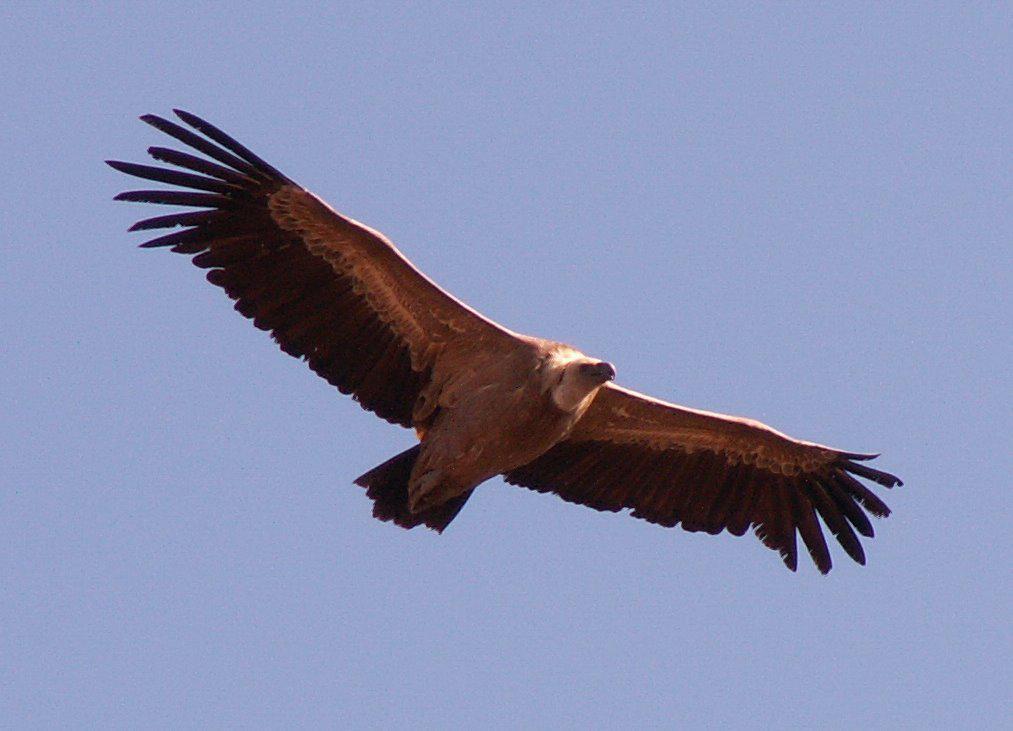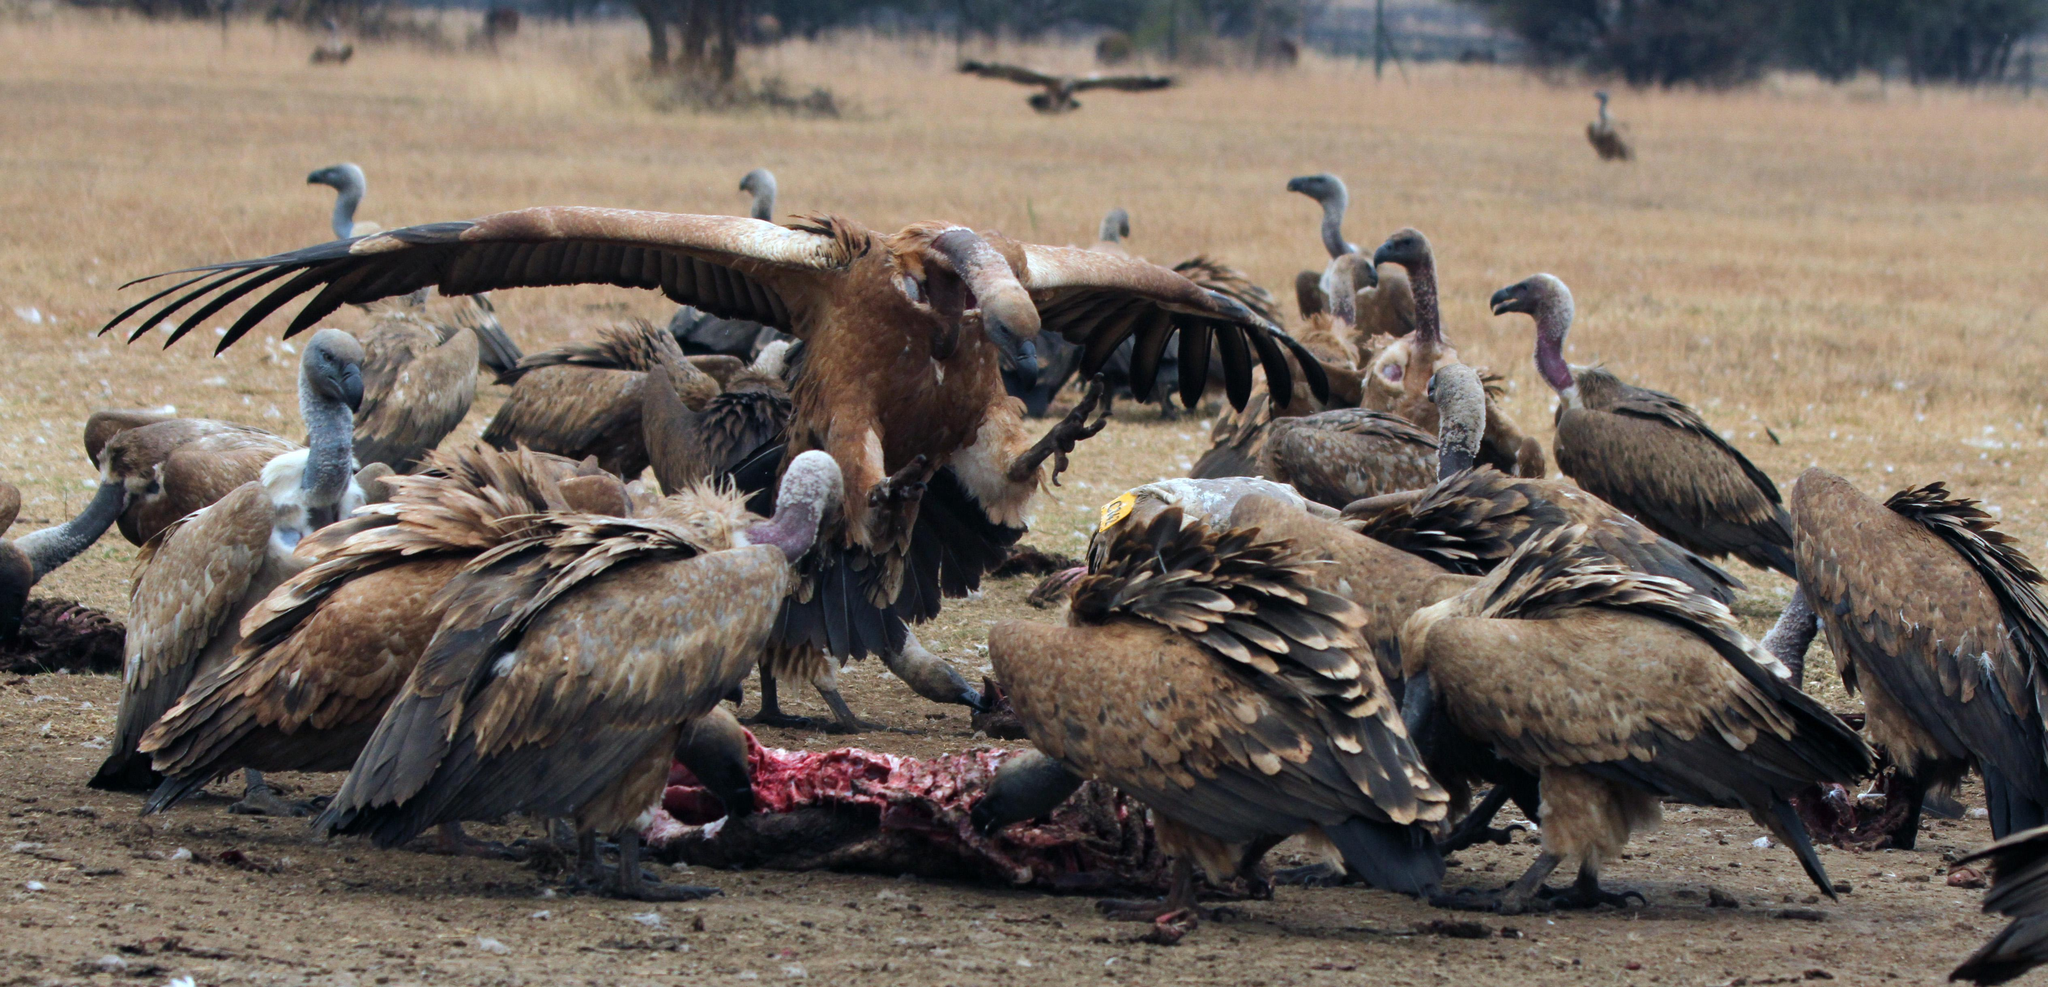The first image is the image on the left, the second image is the image on the right. Analyze the images presented: Is the assertion "The left and right image contains the same vultures." valid? Answer yes or no. No. The first image is the image on the left, the second image is the image on the right. Analyze the images presented: Is the assertion "One image shows a white-headed vulture in flight with its wings spread." valid? Answer yes or no. Yes. 